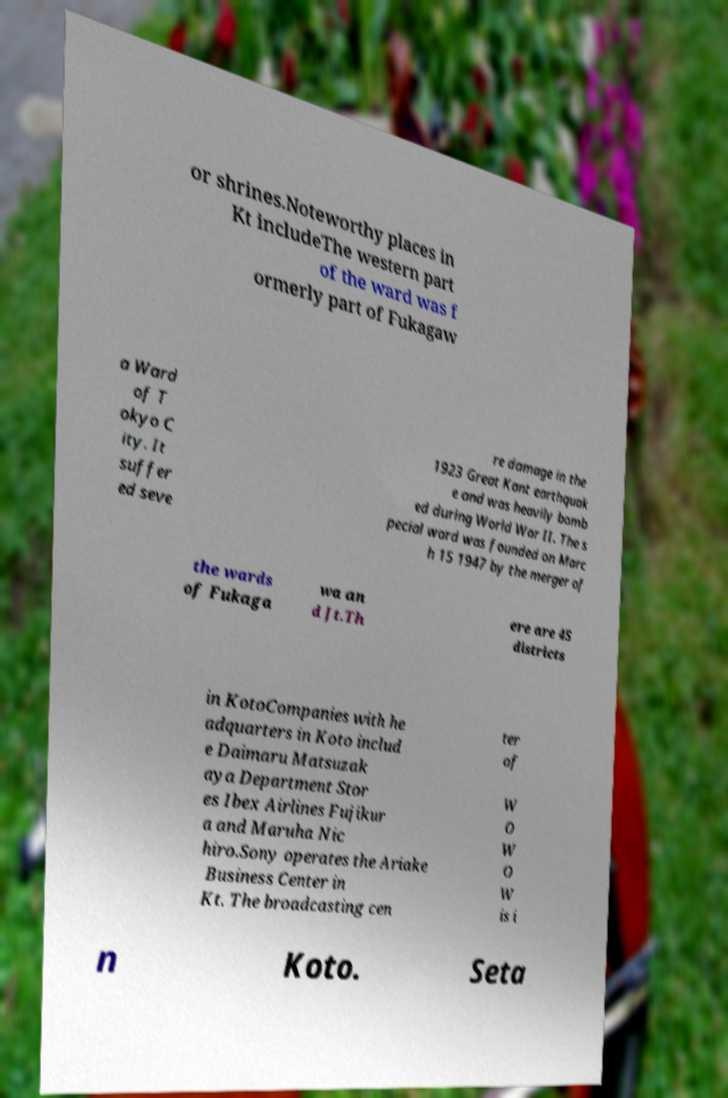Can you read and provide the text displayed in the image?This photo seems to have some interesting text. Can you extract and type it out for me? or shrines.Noteworthy places in Kt includeThe western part of the ward was f ormerly part of Fukagaw a Ward of T okyo C ity. It suffer ed seve re damage in the 1923 Great Kant earthquak e and was heavily bomb ed during World War II. The s pecial ward was founded on Marc h 15 1947 by the merger of the wards of Fukaga wa an d Jt.Th ere are 45 districts in KotoCompanies with he adquarters in Koto includ e Daimaru Matsuzak aya Department Stor es Ibex Airlines Fujikur a and Maruha Nic hiro.Sony operates the Ariake Business Center in Kt. The broadcasting cen ter of W O W O W is i n Koto. Seta 